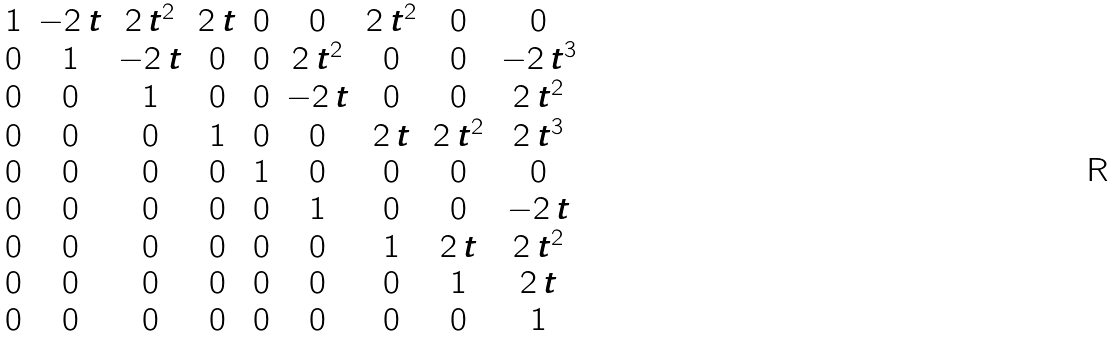<formula> <loc_0><loc_0><loc_500><loc_500>\begin{matrix} 1 & - 2 \, t & 2 \, t ^ { 2 } & 2 \, t & 0 & 0 & 2 \, t ^ { 2 } & 0 & 0 \\ 0 & 1 & - 2 \, t & 0 & 0 & 2 \, t ^ { 2 } & 0 & 0 & - 2 \, t ^ { 3 } \\ 0 & 0 & 1 & 0 & 0 & - 2 \, t & 0 & 0 & 2 \, t ^ { 2 } \\ 0 & 0 & 0 & 1 & 0 & 0 & 2 \, t & 2 \, t ^ { 2 } & 2 \, t ^ { 3 } \\ 0 & 0 & 0 & 0 & 1 & 0 & 0 & 0 & 0 \\ 0 & 0 & 0 & 0 & 0 & 1 & 0 & 0 & - 2 \, t \\ 0 & 0 & 0 & 0 & 0 & 0 & 1 & 2 \, t & 2 \, t ^ { 2 } \\ 0 & 0 & 0 & 0 & 0 & 0 & 0 & 1 & 2 \, t \\ 0 & 0 & 0 & 0 & 0 & 0 & 0 & 0 & 1 \end{matrix}</formula> 